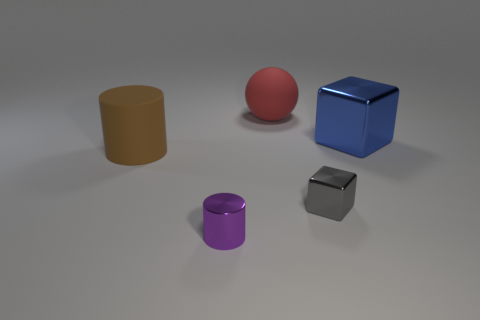Can you describe the shapes and colors of the objects in the image? Certainly! There are five objects in total: a brown cylinder, a red sphere, a blue cube, a purple cylinder that's smaller than the brown one, and a smaller gray cube. 